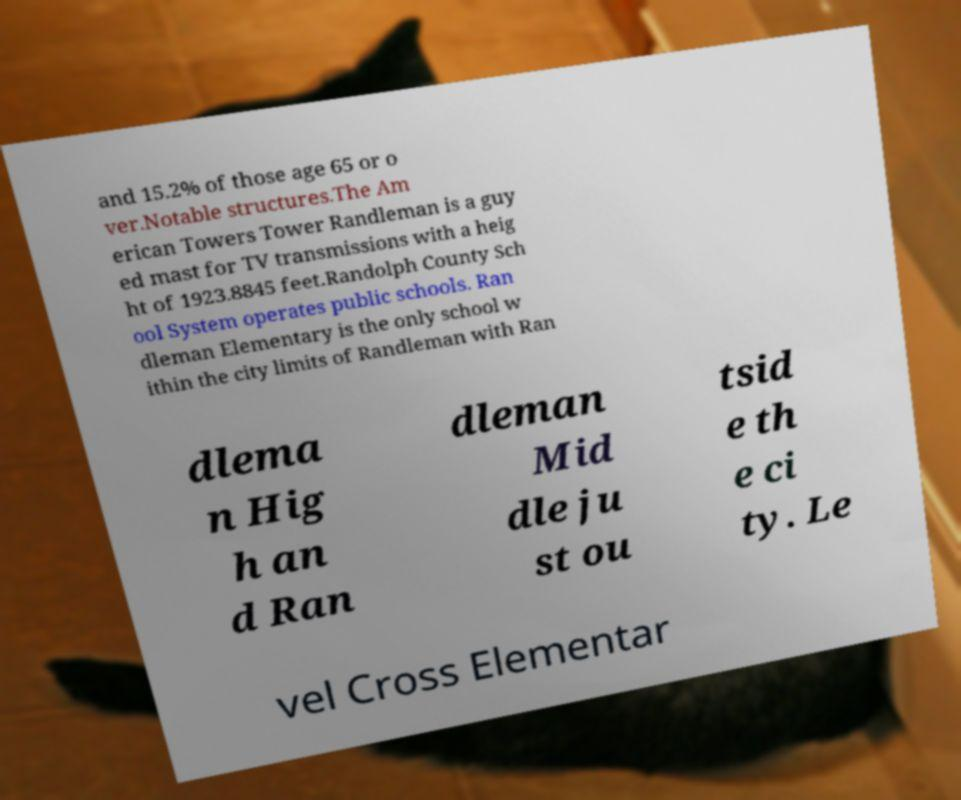There's text embedded in this image that I need extracted. Can you transcribe it verbatim? and 15.2% of those age 65 or o ver.Notable structures.The Am erican Towers Tower Randleman is a guy ed mast for TV transmissions with a heig ht of 1923.8845 feet.Randolph County Sch ool System operates public schools. Ran dleman Elementary is the only school w ithin the city limits of Randleman with Ran dlema n Hig h an d Ran dleman Mid dle ju st ou tsid e th e ci ty. Le vel Cross Elementar 